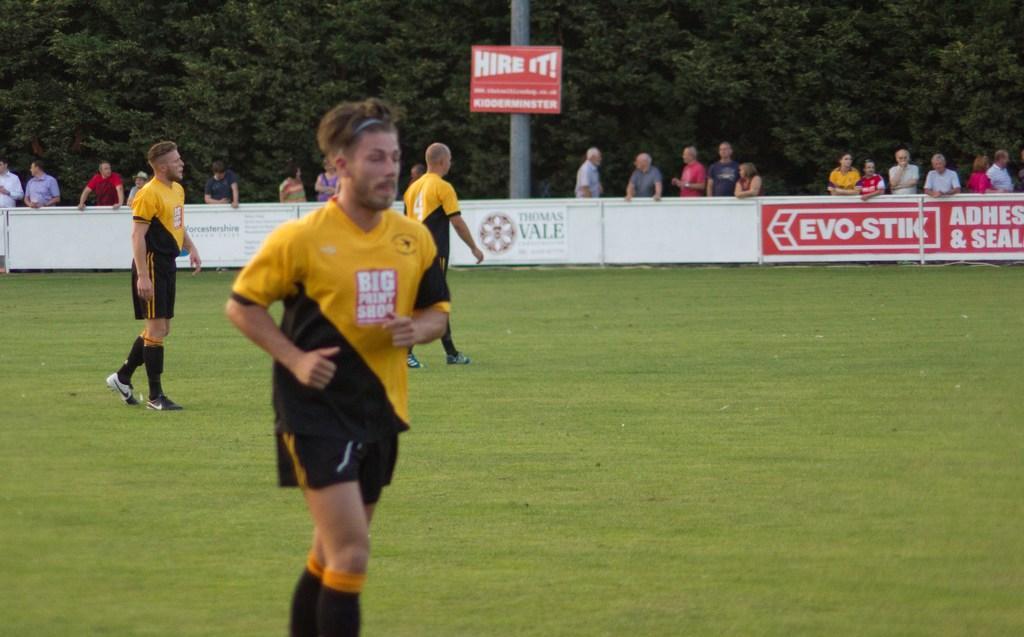Please provide a concise description of this image. In this image there is a ground on which there are three players. In the background there is a boundary. Behind the boundary there are few spectators standing and watching the game. In the middle there is a pole to which there is a board. In the background there are trees. 